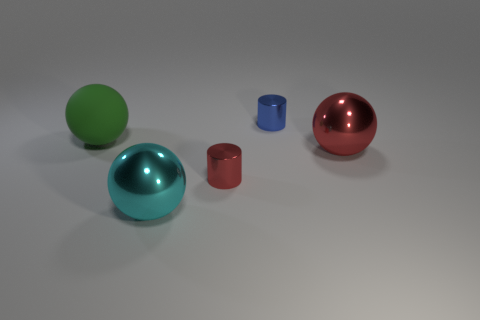There is another matte object that is the same shape as the big red thing; what is its color?
Your response must be concise. Green. Is the size of the blue metallic object the same as the red ball?
Your answer should be very brief. No. Are there an equal number of big metallic objects left of the blue cylinder and big cyan objects?
Keep it short and to the point. Yes. Are there any large red spheres in front of the small cylinder that is on the left side of the blue cylinder?
Ensure brevity in your answer.  No. There is a sphere that is on the left side of the metallic thing that is in front of the red metallic object to the left of the blue metallic cylinder; what is its size?
Give a very brief answer. Large. What material is the red thing that is right of the small metallic cylinder that is behind the matte thing?
Your response must be concise. Metal. Is there a tiny red shiny object of the same shape as the large red object?
Ensure brevity in your answer.  No. What shape is the small red metal object?
Provide a short and direct response. Cylinder. What is the material of the cylinder in front of the large metal ball right of the large metal thing that is in front of the red metal cylinder?
Offer a very short reply. Metal. Is the number of red shiny things to the left of the big cyan metallic thing greater than the number of cyan metallic spheres?
Provide a short and direct response. No. 